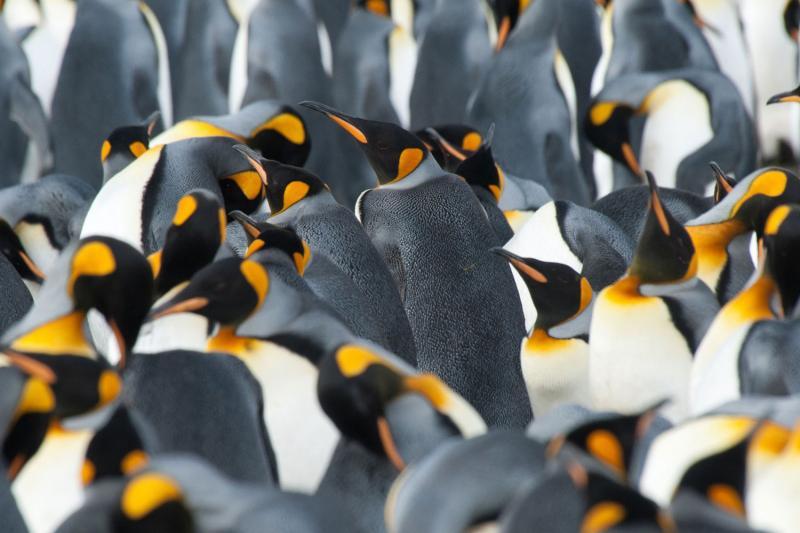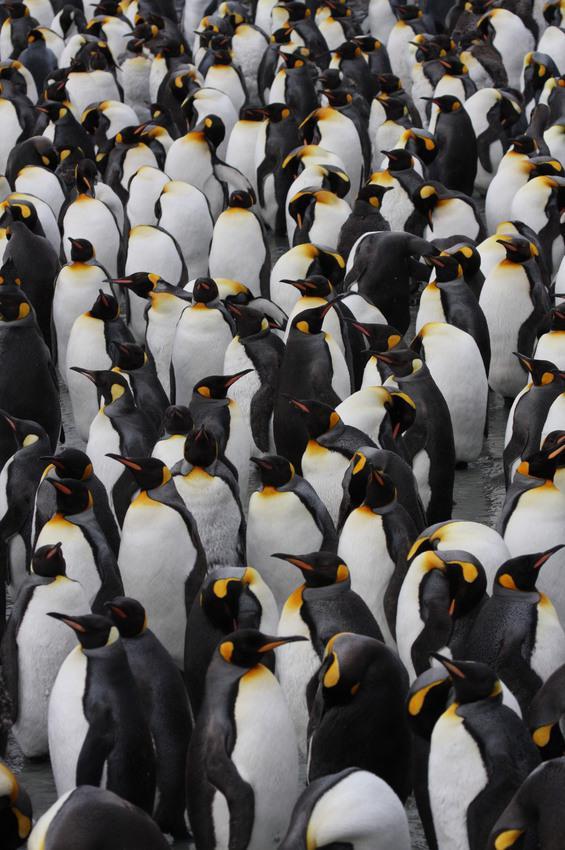The first image is the image on the left, the second image is the image on the right. Examine the images to the left and right. Is the description "At least one of the penguins has an open beak in one of the images." accurate? Answer yes or no. No. 